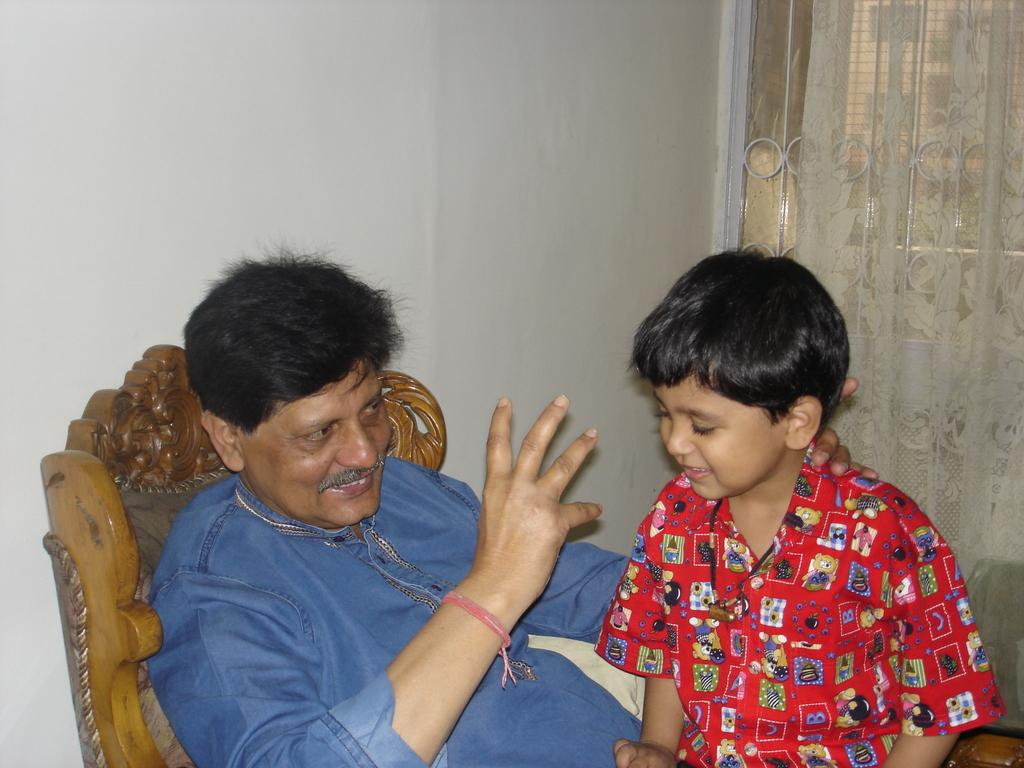What is the main subject in the image? There is a kid in the image. How is the kid positioned in relation to the person? The kid is sitting on a person's lap. What is the person sitting on? The person is sitting on a chair. What can be seen behind the person? There is a wall behind the person. What type of window is present beside the person? There are curtains on a grill window beside the person. What type of stitch is being used to sew the plants in the image? There are no plants or stitching present in the image. Can you tell me how many faucets are visible in the image? There are no faucets visible in the image. 